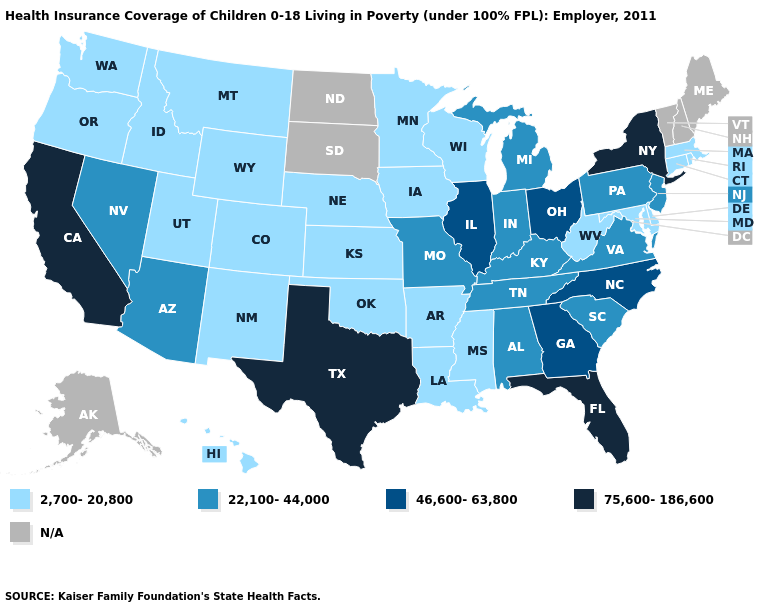What is the lowest value in states that border Iowa?
Write a very short answer. 2,700-20,800. What is the highest value in the South ?
Give a very brief answer. 75,600-186,600. What is the value of Indiana?
Concise answer only. 22,100-44,000. What is the lowest value in the West?
Short answer required. 2,700-20,800. What is the value of Maine?
Give a very brief answer. N/A. Name the states that have a value in the range 2,700-20,800?
Concise answer only. Arkansas, Colorado, Connecticut, Delaware, Hawaii, Idaho, Iowa, Kansas, Louisiana, Maryland, Massachusetts, Minnesota, Mississippi, Montana, Nebraska, New Mexico, Oklahoma, Oregon, Rhode Island, Utah, Washington, West Virginia, Wisconsin, Wyoming. What is the value of Missouri?
Keep it brief. 22,100-44,000. Name the states that have a value in the range 46,600-63,800?
Give a very brief answer. Georgia, Illinois, North Carolina, Ohio. Does the map have missing data?
Answer briefly. Yes. What is the value of Minnesota?
Short answer required. 2,700-20,800. Name the states that have a value in the range 22,100-44,000?
Keep it brief. Alabama, Arizona, Indiana, Kentucky, Michigan, Missouri, Nevada, New Jersey, Pennsylvania, South Carolina, Tennessee, Virginia. What is the value of Vermont?
Write a very short answer. N/A. What is the value of Montana?
Answer briefly. 2,700-20,800. 